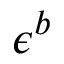<formula> <loc_0><loc_0><loc_500><loc_500>\epsilon ^ { b }</formula> 